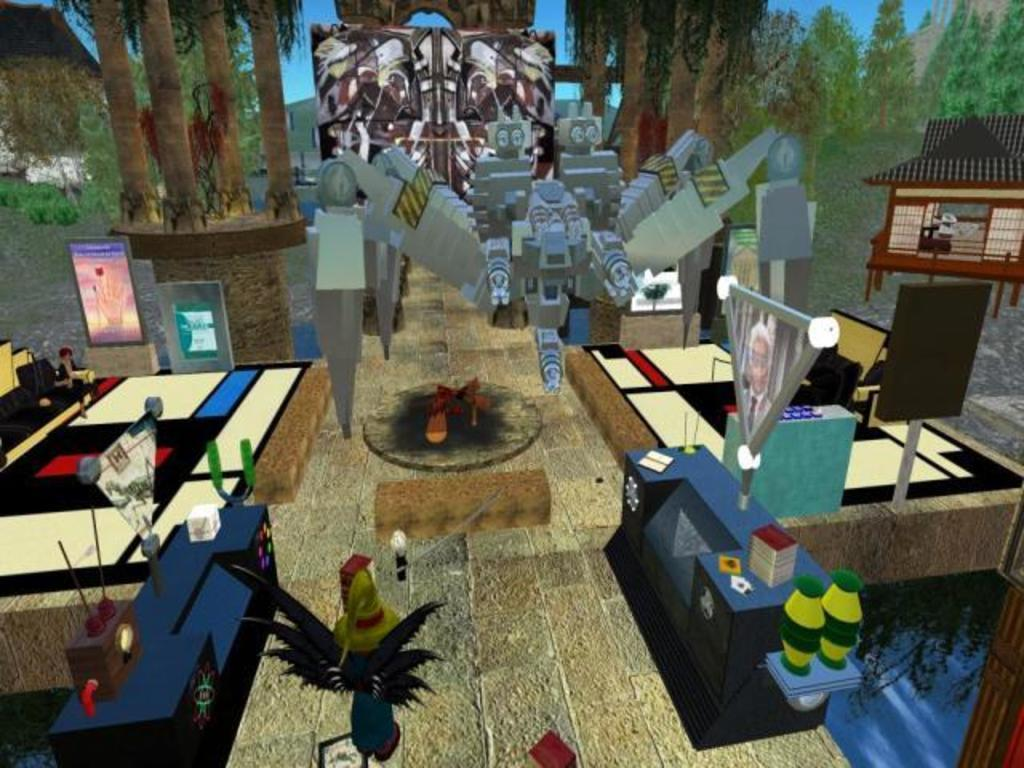What type of picture is in the image? The image contains an animated picture. What can be seen in the background of the animated picture? There are trees in the background of the image. What else is visible in the background of the image? The sky is visible in the background of the image. How many passengers are visible in the image? There are no passengers present in the image, as it contains an animated picture with trees and the sky in the background. What type of star can be seen in the image? There is no star visible in the image; it only contains an animated picture with trees and the sky in the background. 